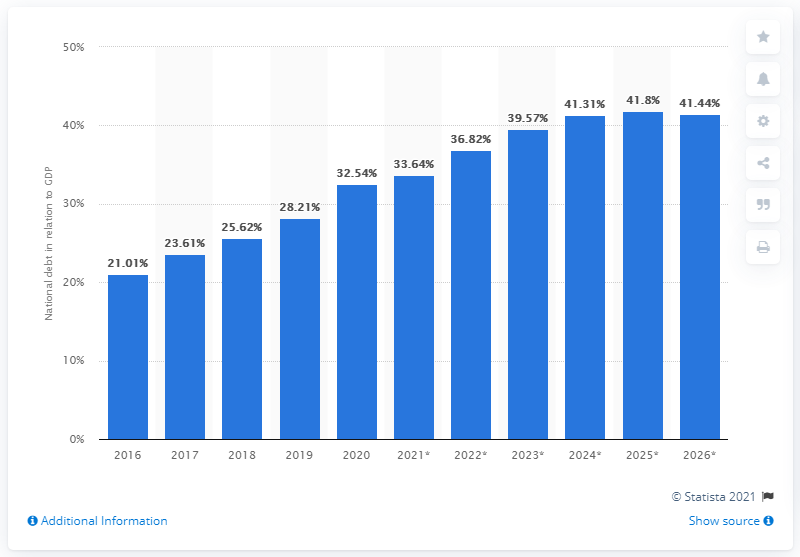What percentage of Chile's GDP did the national debt amount to in 2020? According to the bar graph, Chile's national debt amounted to approximately 28.2% of its GDP in 2020. The graph represents a series of percentages over several years, indicating an upward trend in the national debt relative to GDP. 